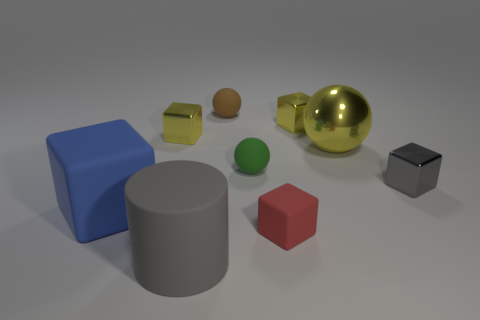Are there the same number of gray metallic cubes that are left of the gray metallic block and blue objects?
Your answer should be very brief. No. How many other objects are the same shape as the blue object?
Make the answer very short. 4. What is the shape of the green rubber object?
Your answer should be very brief. Sphere. Is the material of the gray cube the same as the brown ball?
Provide a short and direct response. No. Are there an equal number of small matte things that are on the right side of the green ball and tiny green spheres that are behind the brown object?
Offer a terse response. No. There is a yellow metallic block to the left of the tiny block that is in front of the small gray metal thing; are there any small yellow shiny cubes left of it?
Provide a short and direct response. No. Do the blue block and the brown ball have the same size?
Offer a terse response. No. The rubber sphere that is behind the yellow block that is left of the big rubber object that is right of the big cube is what color?
Keep it short and to the point. Brown. How many shiny blocks have the same color as the big metallic ball?
Give a very brief answer. 2. How many big things are yellow shiny blocks or shiny cubes?
Give a very brief answer. 0. 